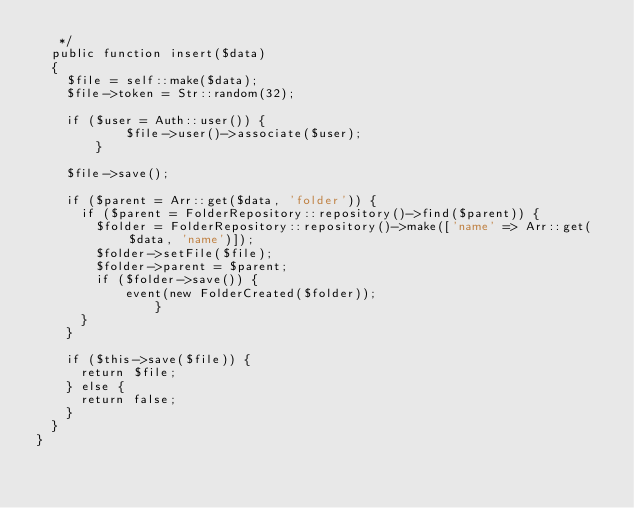Convert code to text. <code><loc_0><loc_0><loc_500><loc_500><_PHP_>	 */
	public function insert($data)
	{
		$file = self::make($data);
		$file->token = Str::random(32);

		if ($user = Auth::user()) {
            $file->user()->associate($user);
        }

		$file->save();

		if ($parent = Arr::get($data, 'folder')) {
			if ($parent = FolderRepository::repository()->find($parent)) {
				$folder = FolderRepository::repository()->make(['name' => Arr::get($data, 'name')]);
				$folder->setFile($file);
				$folder->parent = $parent;
				if ($folder->save()) {
				    event(new FolderCreated($folder));
                }
			}
		}

		if ($this->save($file)) {
			return $file;
		} else {
			return false;
		}
	}
}
</code> 